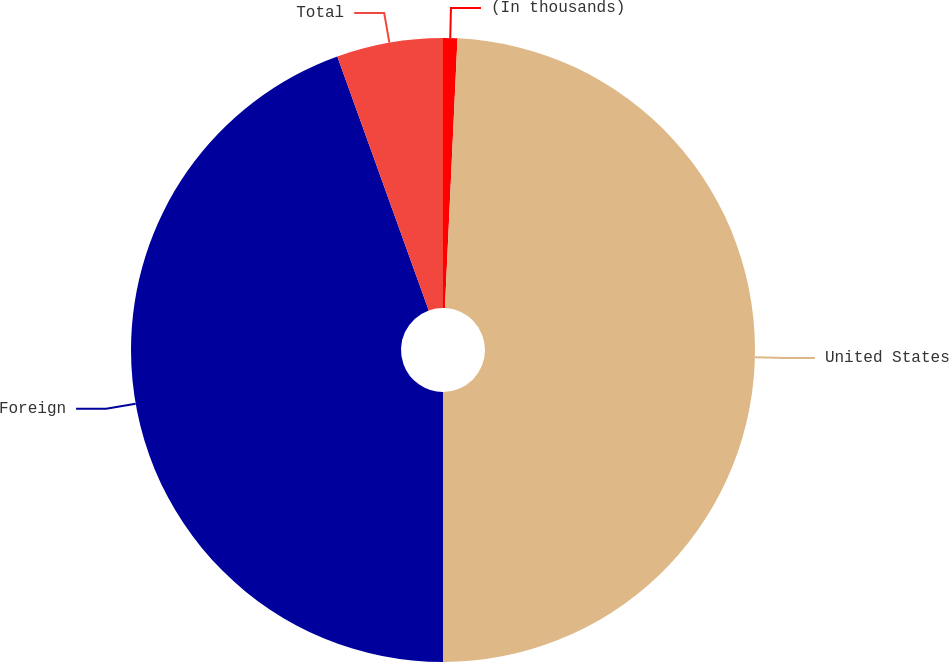Convert chart to OTSL. <chart><loc_0><loc_0><loc_500><loc_500><pie_chart><fcel>(In thousands)<fcel>United States<fcel>Foreign<fcel>Total<nl><fcel>0.74%<fcel>49.26%<fcel>44.5%<fcel>5.5%<nl></chart> 